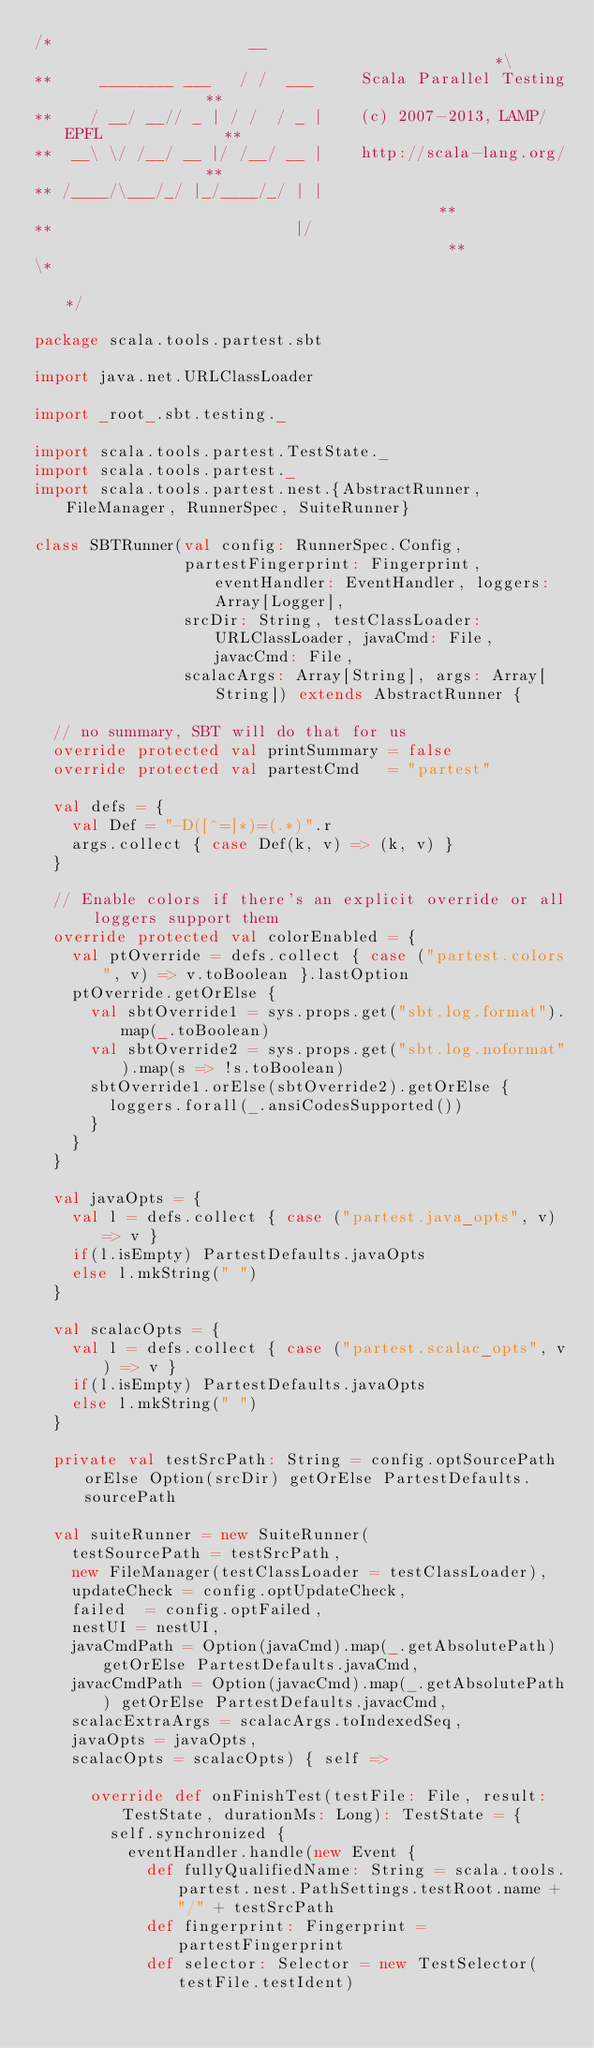<code> <loc_0><loc_0><loc_500><loc_500><_Scala_>/*                     __                                               *\
**     ________ ___   / /  ___     Scala Parallel Testing               **
**    / __/ __// _ | / /  / _ |    (c) 2007-2013, LAMP/EPFL             **
**  __\ \/ /__/ __ |/ /__/ __ |    http://scala-lang.org/               **
** /____/\___/_/ |_/____/_/ | |                                         **
**                          |/                                          **
\*                                                                      */

package scala.tools.partest.sbt

import java.net.URLClassLoader

import _root_.sbt.testing._

import scala.tools.partest.TestState._
import scala.tools.partest._
import scala.tools.partest.nest.{AbstractRunner, FileManager, RunnerSpec, SuiteRunner}

class SBTRunner(val config: RunnerSpec.Config,
                partestFingerprint: Fingerprint, eventHandler: EventHandler, loggers: Array[Logger],
                srcDir: String, testClassLoader: URLClassLoader, javaCmd: File, javacCmd: File,
                scalacArgs: Array[String], args: Array[String]) extends AbstractRunner {

  // no summary, SBT will do that for us
  override protected val printSummary = false
  override protected val partestCmd   = "partest"

  val defs = {
    val Def = "-D([^=]*)=(.*)".r
    args.collect { case Def(k, v) => (k, v) }
  }

  // Enable colors if there's an explicit override or all loggers support them
  override protected val colorEnabled = {
    val ptOverride = defs.collect { case ("partest.colors", v) => v.toBoolean }.lastOption
    ptOverride.getOrElse {
      val sbtOverride1 = sys.props.get("sbt.log.format").map(_.toBoolean)
      val sbtOverride2 = sys.props.get("sbt.log.noformat").map(s => !s.toBoolean)
      sbtOverride1.orElse(sbtOverride2).getOrElse {
        loggers.forall(_.ansiCodesSupported())
      }
    }
  }

  val javaOpts = {
    val l = defs.collect { case ("partest.java_opts", v) => v }
    if(l.isEmpty) PartestDefaults.javaOpts
    else l.mkString(" ")
  }

  val scalacOpts = {
    val l = defs.collect { case ("partest.scalac_opts", v) => v }
    if(l.isEmpty) PartestDefaults.javaOpts
    else l.mkString(" ")
  }

  private val testSrcPath: String = config.optSourcePath orElse Option(srcDir) getOrElse PartestDefaults.sourcePath

  val suiteRunner = new SuiteRunner(
    testSourcePath = testSrcPath,
    new FileManager(testClassLoader = testClassLoader),
    updateCheck = config.optUpdateCheck,
    failed  = config.optFailed,
    nestUI = nestUI,
    javaCmdPath = Option(javaCmd).map(_.getAbsolutePath) getOrElse PartestDefaults.javaCmd,
    javacCmdPath = Option(javacCmd).map(_.getAbsolutePath) getOrElse PartestDefaults.javacCmd,
    scalacExtraArgs = scalacArgs.toIndexedSeq,
    javaOpts = javaOpts,
    scalacOpts = scalacOpts) { self =>

      override def onFinishTest(testFile: File, result: TestState, durationMs: Long): TestState = {
        self.synchronized {
          eventHandler.handle(new Event {
            def fullyQualifiedName: String = scala.tools.partest.nest.PathSettings.testRoot.name + "/" + testSrcPath
            def fingerprint: Fingerprint = partestFingerprint
            def selector: Selector = new TestSelector(testFile.testIdent)</code> 